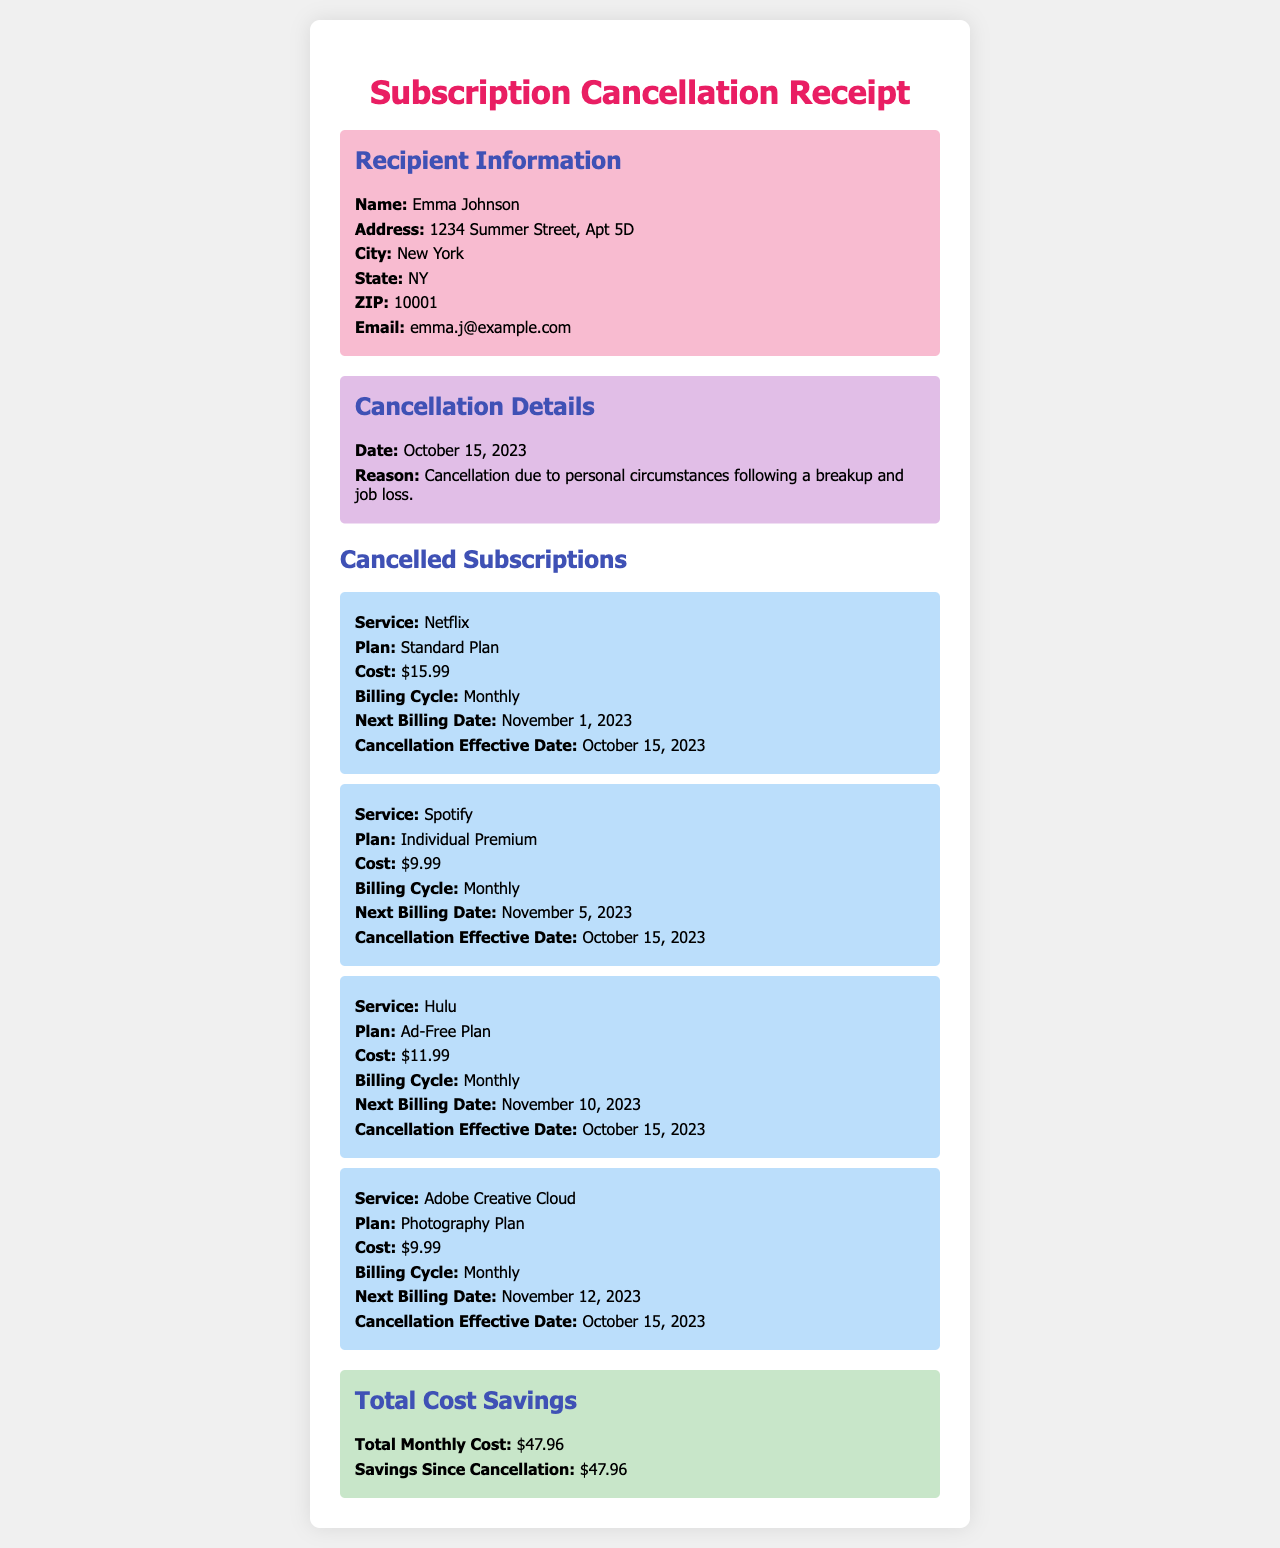What is the recipient's name? The recipient's name is stated in the 'Recipient Information' section of the document.
Answer: Emma Johnson When was the cancellation effective? The effective date of cancellation is mentioned in the 'Cancellation Details' section.
Answer: October 15, 2023 What is the total monthly cost of the cancelled subscriptions? The total monthly cost is provided in the 'Total Cost Savings' section, calculated from all cancelled services.
Answer: $47.96 Which service had the highest cancellation cost? This can be deduced by comparing the costs listed for each cancelled subscription.
Answer: Netflix What is the reason for cancellation? The document provides the cancellation reason in the 'Cancellation Details' section.
Answer: Cancellation due to personal circumstances following a breakup and job loss What plan did Emma have for Spotify? The plan for Spotify is specified under the 'Cancelled Subscriptions' section.
Answer: Individual Premium What is the next billing date for Hulu? The next billing date is provided in the subscription details for Hulu.
Answer: November 10, 2023 How many subscriptions were cancelled? The number of subscriptions can be counted from the 'Cancelled Subscriptions' section.
Answer: Four What type of document is this? The overall purpose and categorization can be inferred from the title and content structure.
Answer: Subscription Cancellation Receipt 